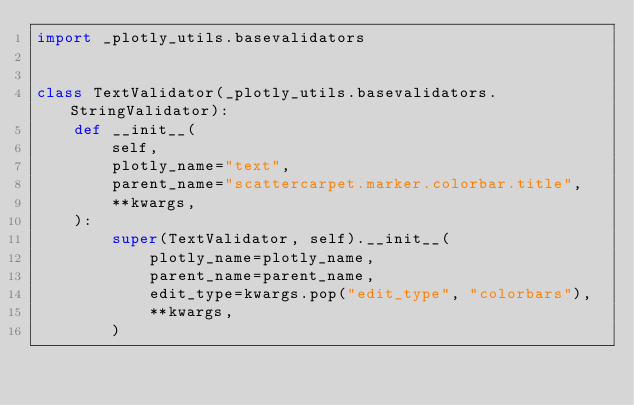<code> <loc_0><loc_0><loc_500><loc_500><_Python_>import _plotly_utils.basevalidators


class TextValidator(_plotly_utils.basevalidators.StringValidator):
    def __init__(
        self,
        plotly_name="text",
        parent_name="scattercarpet.marker.colorbar.title",
        **kwargs,
    ):
        super(TextValidator, self).__init__(
            plotly_name=plotly_name,
            parent_name=parent_name,
            edit_type=kwargs.pop("edit_type", "colorbars"),
            **kwargs,
        )
</code> 